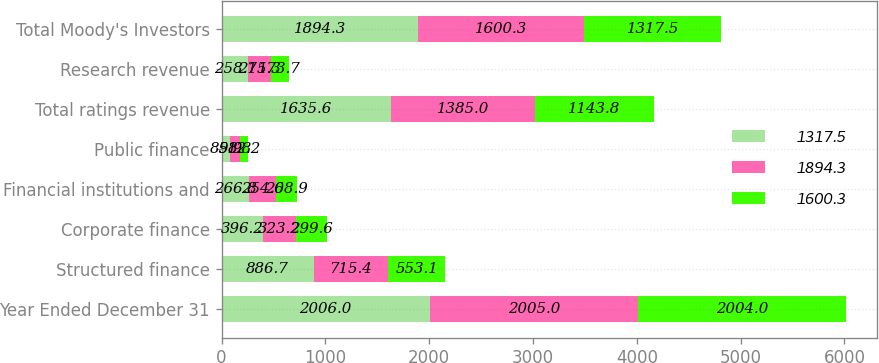Convert chart to OTSL. <chart><loc_0><loc_0><loc_500><loc_500><stacked_bar_chart><ecel><fcel>Year Ended December 31<fcel>Structured finance<fcel>Corporate finance<fcel>Financial institutions and<fcel>Public finance<fcel>Total ratings revenue<fcel>Research revenue<fcel>Total Moody's Investors<nl><fcel>1317.5<fcel>2006<fcel>886.7<fcel>396.2<fcel>266.8<fcel>85.9<fcel>1635.6<fcel>258.7<fcel>1894.3<nl><fcel>1894.3<fcel>2005<fcel>715.4<fcel>323.2<fcel>254.6<fcel>91.8<fcel>1385<fcel>215.3<fcel>1600.3<nl><fcel>1600.3<fcel>2004<fcel>553.1<fcel>299.6<fcel>208.9<fcel>82.2<fcel>1143.8<fcel>173.7<fcel>1317.5<nl></chart> 